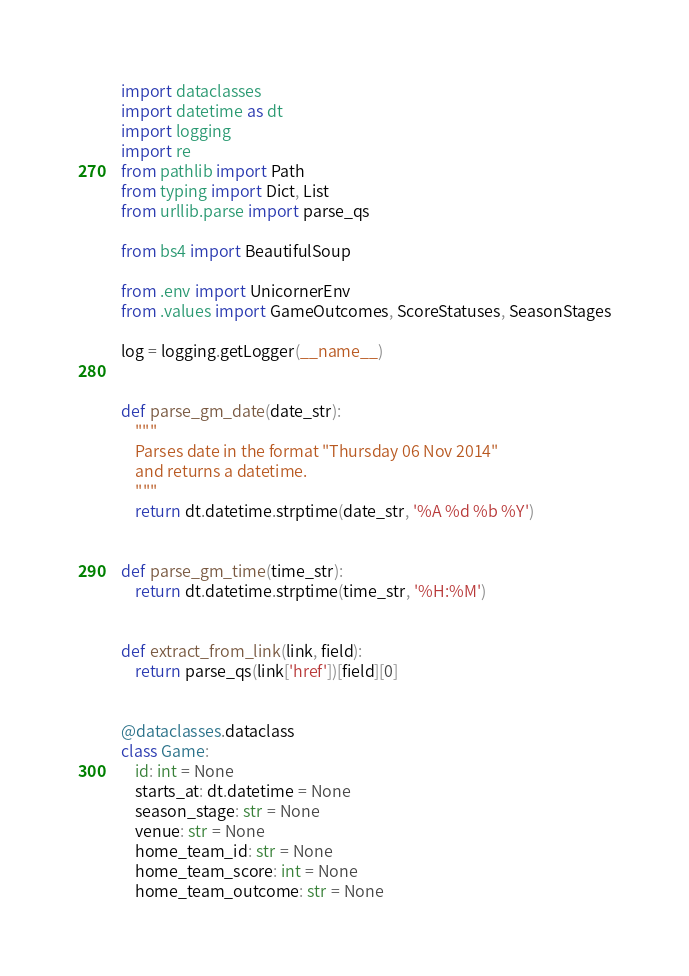Convert code to text. <code><loc_0><loc_0><loc_500><loc_500><_Python_>import dataclasses
import datetime as dt
import logging
import re
from pathlib import Path
from typing import Dict, List
from urllib.parse import parse_qs

from bs4 import BeautifulSoup

from .env import UnicornerEnv
from .values import GameOutcomes, ScoreStatuses, SeasonStages

log = logging.getLogger(__name__)


def parse_gm_date(date_str):
    """
    Parses date in the format "Thursday 06 Nov 2014"
    and returns a datetime.
    """
    return dt.datetime.strptime(date_str, '%A %d %b %Y')


def parse_gm_time(time_str):
    return dt.datetime.strptime(time_str, '%H:%M')


def extract_from_link(link, field):
    return parse_qs(link['href'])[field][0]


@dataclasses.dataclass
class Game:
    id: int = None
    starts_at: dt.datetime = None
    season_stage: str = None
    venue: str = None
    home_team_id: str = None
    home_team_score: int = None
    home_team_outcome: str = None</code> 